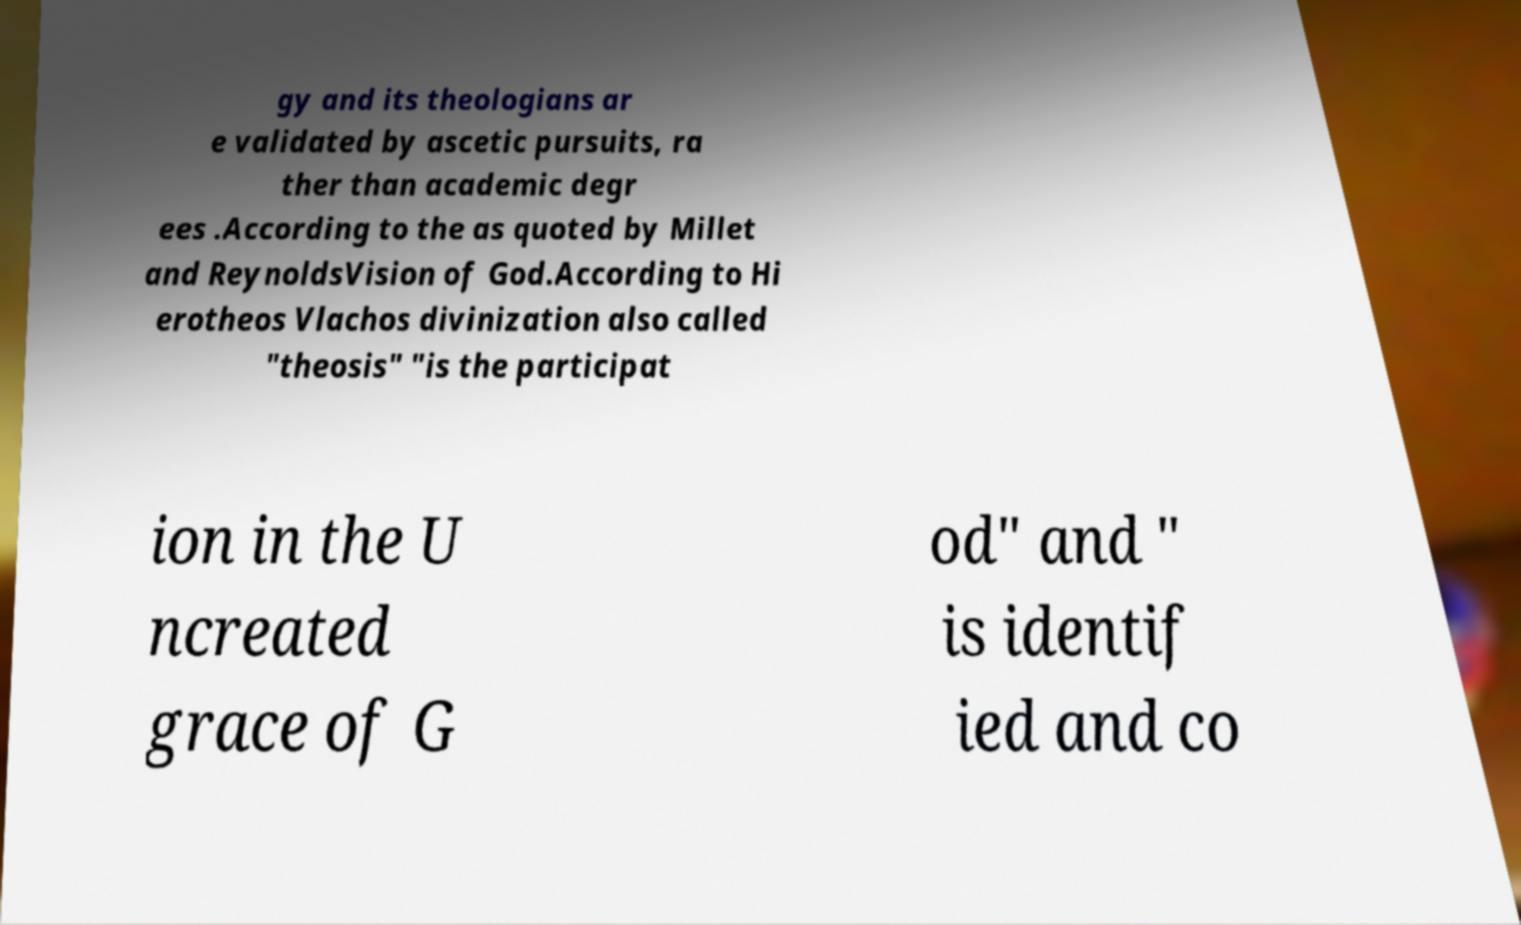Please read and relay the text visible in this image. What does it say? gy and its theologians ar e validated by ascetic pursuits, ra ther than academic degr ees .According to the as quoted by Millet and ReynoldsVision of God.According to Hi erotheos Vlachos divinization also called "theosis" "is the participat ion in the U ncreated grace of G od" and " is identif ied and co 